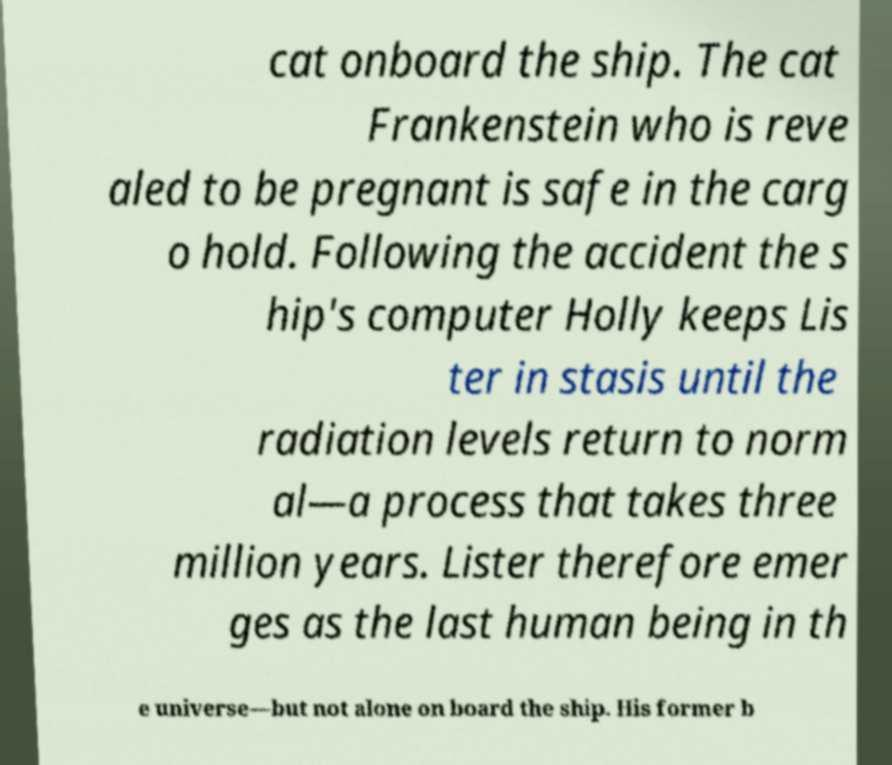Can you accurately transcribe the text from the provided image for me? cat onboard the ship. The cat Frankenstein who is reve aled to be pregnant is safe in the carg o hold. Following the accident the s hip's computer Holly keeps Lis ter in stasis until the radiation levels return to norm al—a process that takes three million years. Lister therefore emer ges as the last human being in th e universe—but not alone on board the ship. His former b 